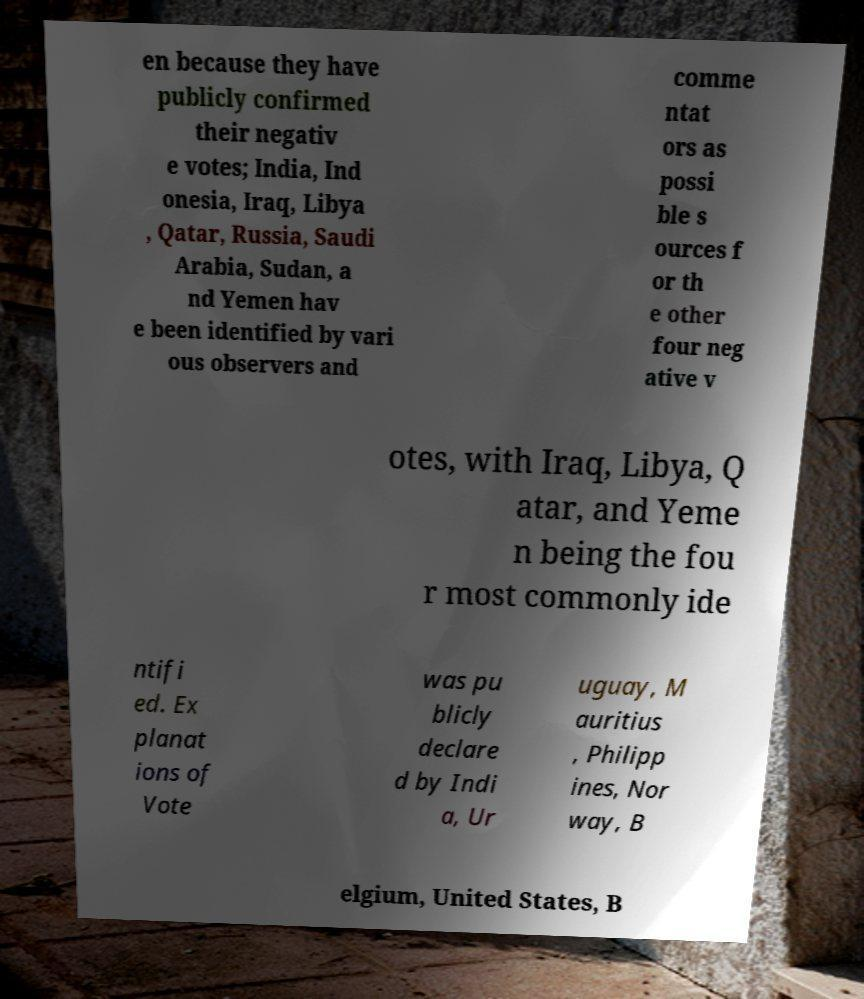Could you extract and type out the text from this image? en because they have publicly confirmed their negativ e votes; India, Ind onesia, Iraq, Libya , Qatar, Russia, Saudi Arabia, Sudan, a nd Yemen hav e been identified by vari ous observers and comme ntat ors as possi ble s ources f or th e other four neg ative v otes, with Iraq, Libya, Q atar, and Yeme n being the fou r most commonly ide ntifi ed. Ex planat ions of Vote was pu blicly declare d by Indi a, Ur uguay, M auritius , Philipp ines, Nor way, B elgium, United States, B 